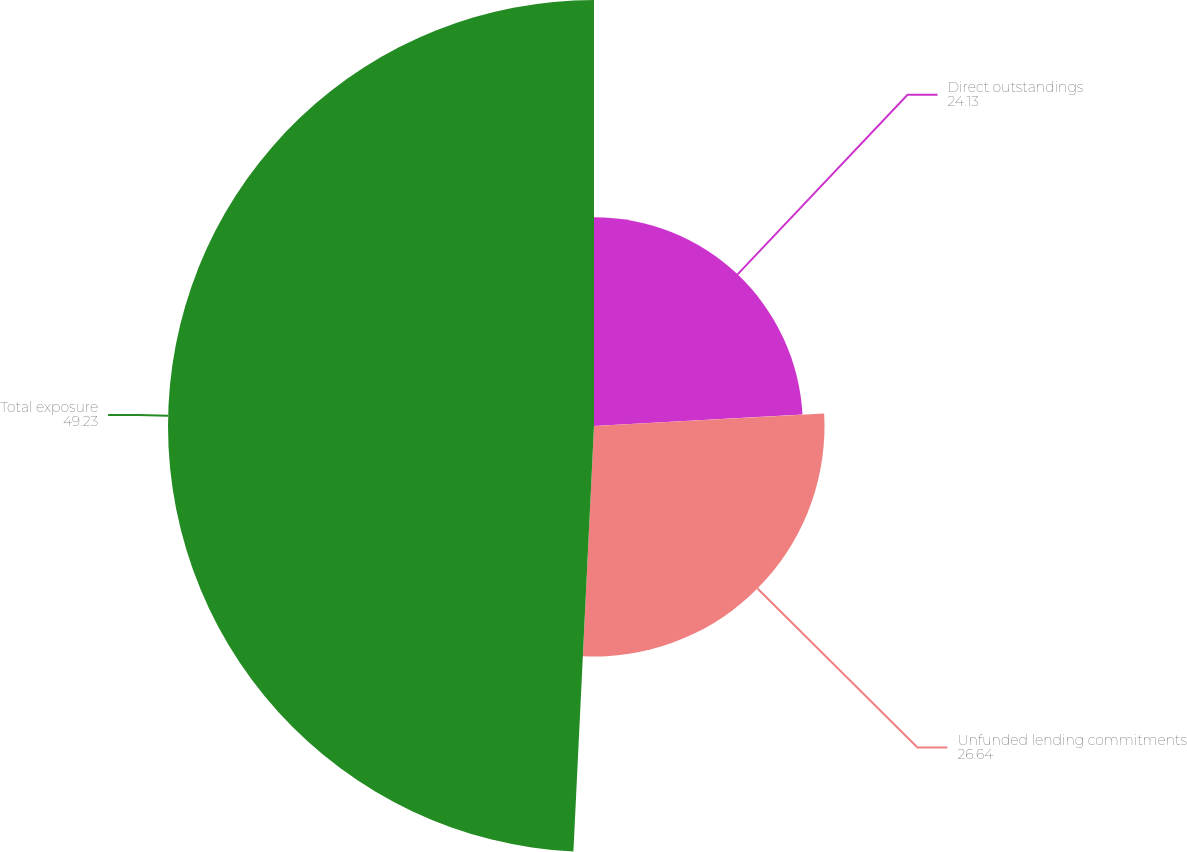Convert chart. <chart><loc_0><loc_0><loc_500><loc_500><pie_chart><fcel>Direct outstandings<fcel>Unfunded lending commitments<fcel>Total exposure<nl><fcel>24.13%<fcel>26.64%<fcel>49.23%<nl></chart> 